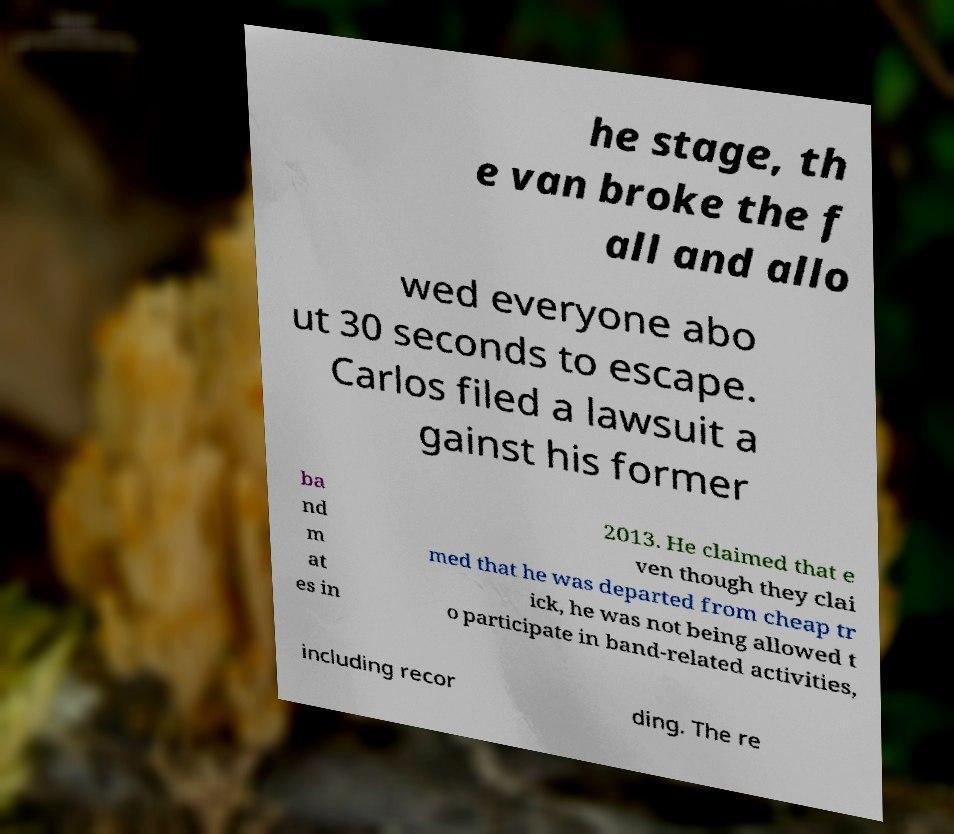Please read and relay the text visible in this image. What does it say? he stage, th e van broke the f all and allo wed everyone abo ut 30 seconds to escape. Carlos filed a lawsuit a gainst his former ba nd m at es in 2013. He claimed that e ven though they clai med that he was departed from cheap tr ick, he was not being allowed t o participate in band-related activities, including recor ding. The re 